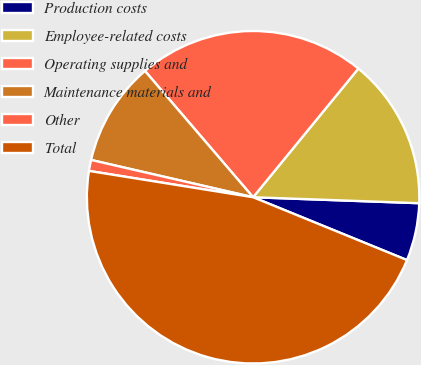Convert chart. <chart><loc_0><loc_0><loc_500><loc_500><pie_chart><fcel>Production costs<fcel>Employee-related costs<fcel>Operating supplies and<fcel>Maintenance materials and<fcel>Other<fcel>Total<nl><fcel>5.6%<fcel>14.66%<fcel>22.19%<fcel>10.13%<fcel>1.07%<fcel>46.37%<nl></chart> 